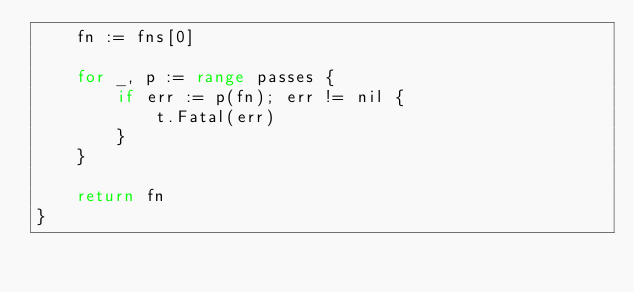Convert code to text. <code><loc_0><loc_0><loc_500><loc_500><_Go_>	fn := fns[0]

	for _, p := range passes {
		if err := p(fn); err != nil {
			t.Fatal(err)
		}
	}

	return fn
}
</code> 